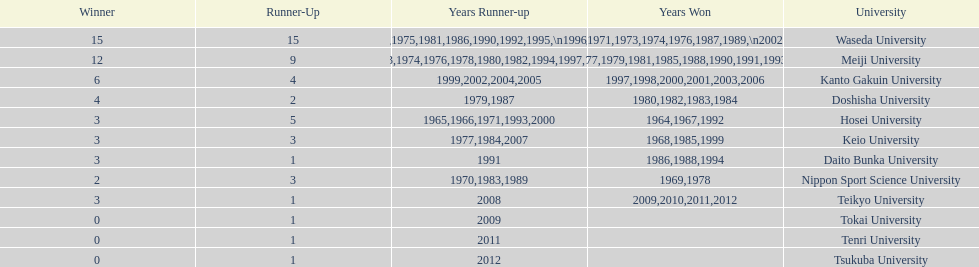Who won the last championship recorded on this table? Teikyo University. 